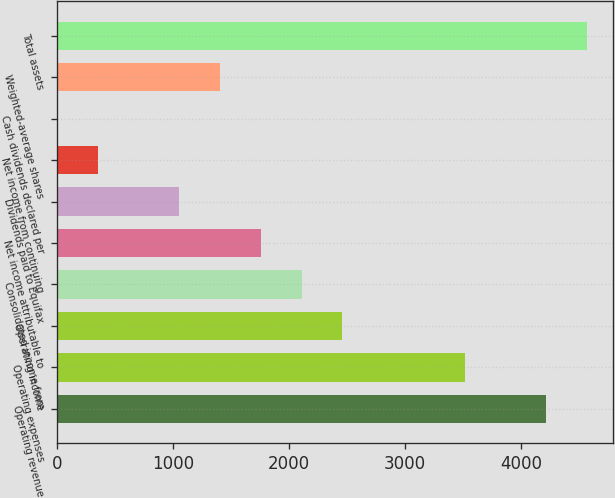Convert chart to OTSL. <chart><loc_0><loc_0><loc_500><loc_500><bar_chart><fcel>Operating revenue<fcel>Operating expenses<fcel>Operating income<fcel>Consolidated income from<fcel>Net income attributable to<fcel>Dividends paid to Equifax<fcel>Net income from continuing<fcel>Cash dividends declared per<fcel>Weighted-average shares<fcel>Total assets<nl><fcel>4214.92<fcel>3512.54<fcel>2458.97<fcel>2107.78<fcel>1756.59<fcel>1054.21<fcel>351.83<fcel>0.64<fcel>1405.4<fcel>4566.11<nl></chart> 